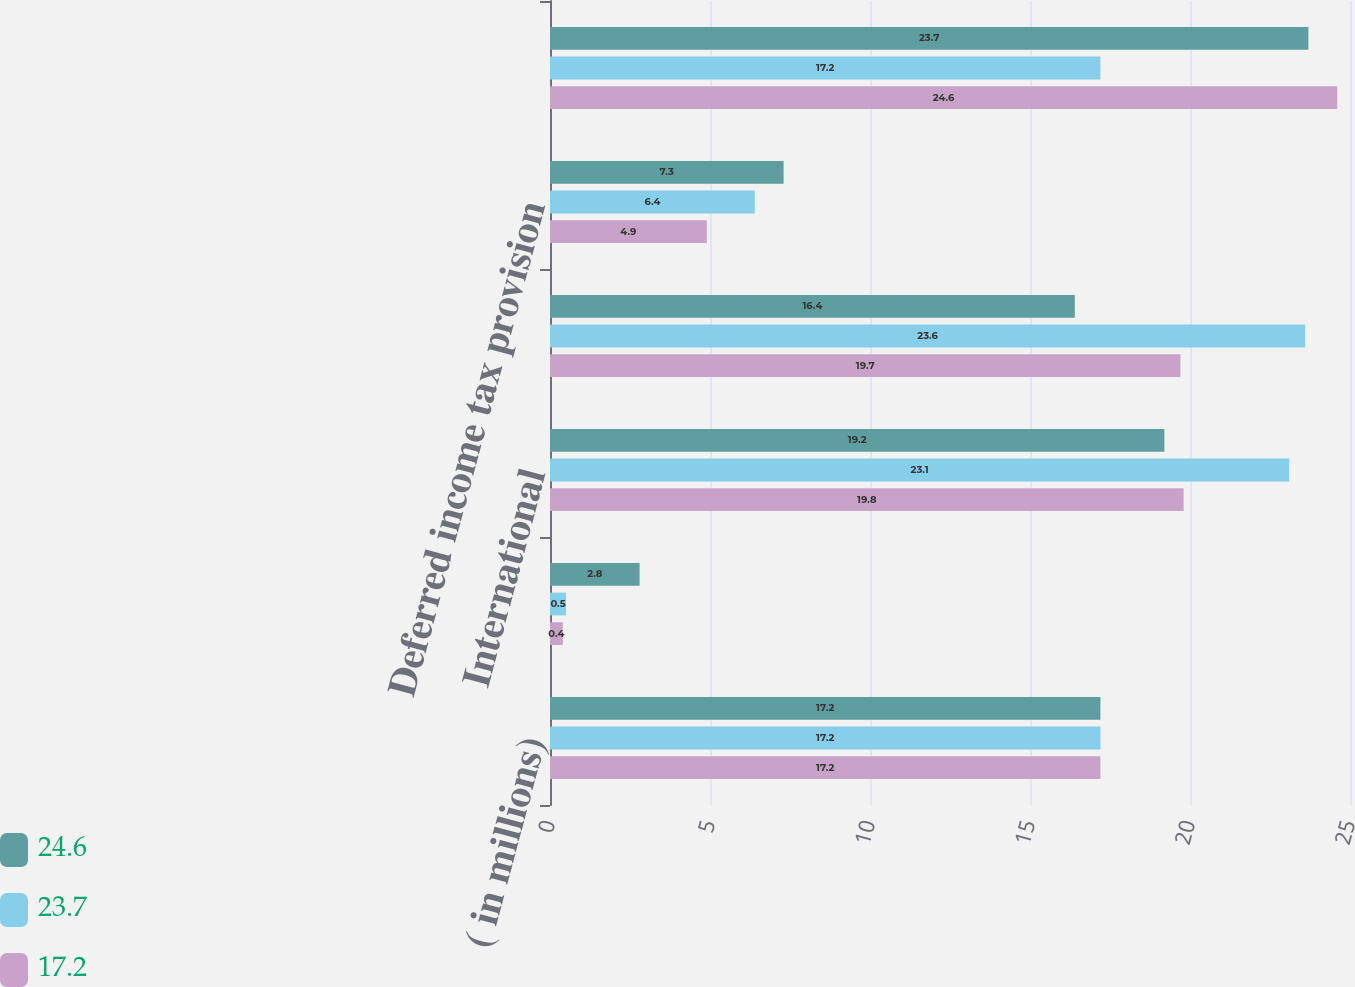Convert chart to OTSL. <chart><loc_0><loc_0><loc_500><loc_500><stacked_bar_chart><ecel><fcel>( in millions)<fcel>Federal<fcel>International<fcel>Current income tax provision<fcel>Deferred income tax provision<fcel>Provision for income taxes<nl><fcel>24.6<fcel>17.2<fcel>2.8<fcel>19.2<fcel>16.4<fcel>7.3<fcel>23.7<nl><fcel>23.7<fcel>17.2<fcel>0.5<fcel>23.1<fcel>23.6<fcel>6.4<fcel>17.2<nl><fcel>17.2<fcel>17.2<fcel>0.4<fcel>19.8<fcel>19.7<fcel>4.9<fcel>24.6<nl></chart> 